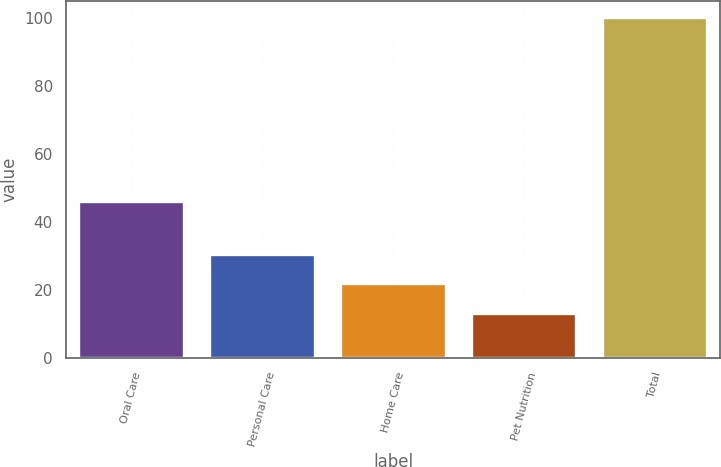Convert chart. <chart><loc_0><loc_0><loc_500><loc_500><bar_chart><fcel>Oral Care<fcel>Personal Care<fcel>Home Care<fcel>Pet Nutrition<fcel>Total<nl><fcel>46<fcel>30.4<fcel>21.7<fcel>13<fcel>100<nl></chart> 